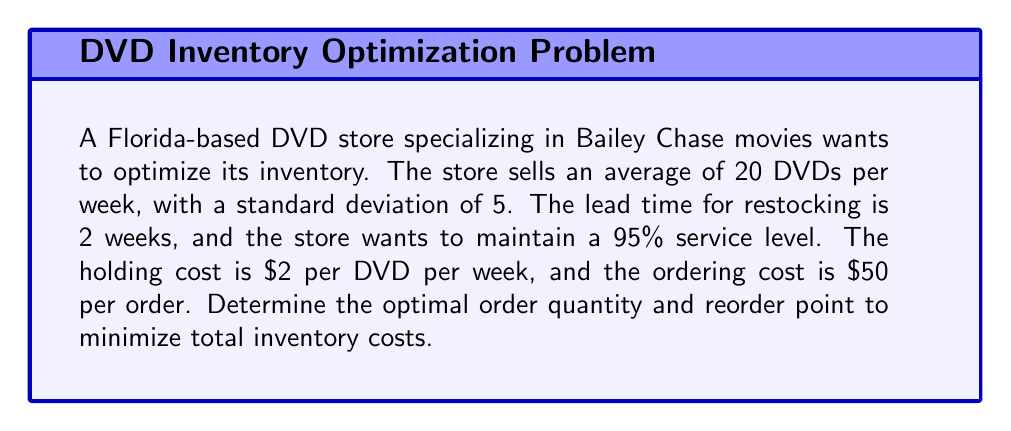Show me your answer to this math problem. To solve this problem, we'll use the Economic Order Quantity (EOQ) model and the concept of safety stock. Let's break it down step by step:

1. Calculate the Economic Order Quantity (EOQ):
   The EOQ formula is: $$ Q = \sqrt{\frac{2DS}{H}} $$
   Where:
   $D$ = Annual demand = 20 DVDs/week * 52 weeks = 1040 DVDs/year
   $S$ = Ordering cost = $50 per order
   $H$ = Holding cost = $2 per DVD per week * 52 weeks = $104 per DVD per year

   $$ Q = \sqrt{\frac{2 * 1040 * 50}{104}} \approx 100 \text{ DVDs} $$

2. Calculate the safety stock:
   For a 95% service level, we use a z-score of 1.645 (from the standard normal distribution table).
   Safety Stock = $z * \sigma * \sqrt{L}$
   Where:
   $z$ = 1.645 (95% service level)
   $\sigma$ = Standard deviation of weekly demand = 5 DVDs
   $L$ = Lead time in weeks = 2 weeks

   Safety Stock = $1.645 * 5 * \sqrt{2} \approx 12 \text{ DVDs}$

3. Calculate the Reorder Point (ROP):
   ROP = (Average demand during lead time) + Safety Stock
   Average weekly demand = 20 DVDs
   Lead time = 2 weeks
   
   ROP = $(20 * 2) + 12 = 52 \text{ DVDs}$

4. Calculate the total annual inventory cost:
   Total Cost = Ordering Cost + Holding Cost
   $$ TC = \frac{D}{Q}S + \frac{Q}{2}H + (\text{Safety Stock} * H) $$
   
   $$ TC = \frac{1040}{100}*50 + \frac{100}{2}*104 + (12 * 104) $$
   $$ TC = 520 + 5200 + 1248 = \$6,968 \text{ per year} $$
Answer: The optimal order quantity is 100 DVDs, and the reorder point is 52 DVDs. The total annual inventory cost is $6,968. 